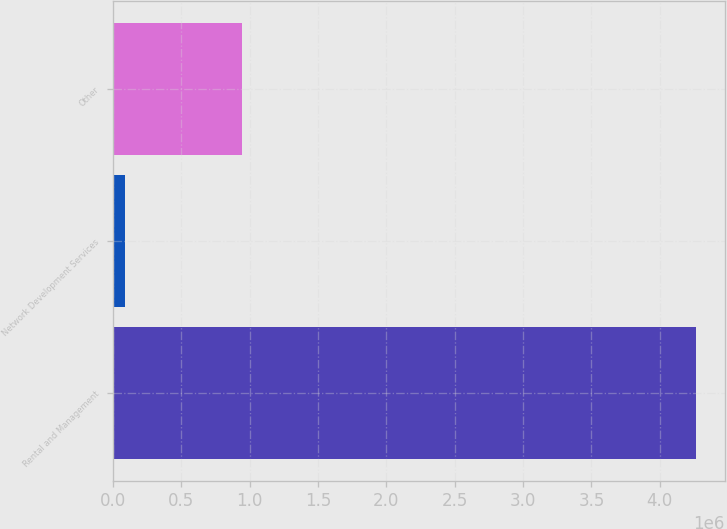<chart> <loc_0><loc_0><loc_500><loc_500><bar_chart><fcel>Rental and Management<fcel>Network Development Services<fcel>Other<nl><fcel>4.26204e+06<fcel>86103<fcel>942514<nl></chart> 